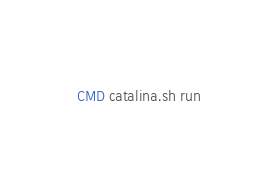<code> <loc_0><loc_0><loc_500><loc_500><_Dockerfile_>CMD catalina.sh run
</code> 